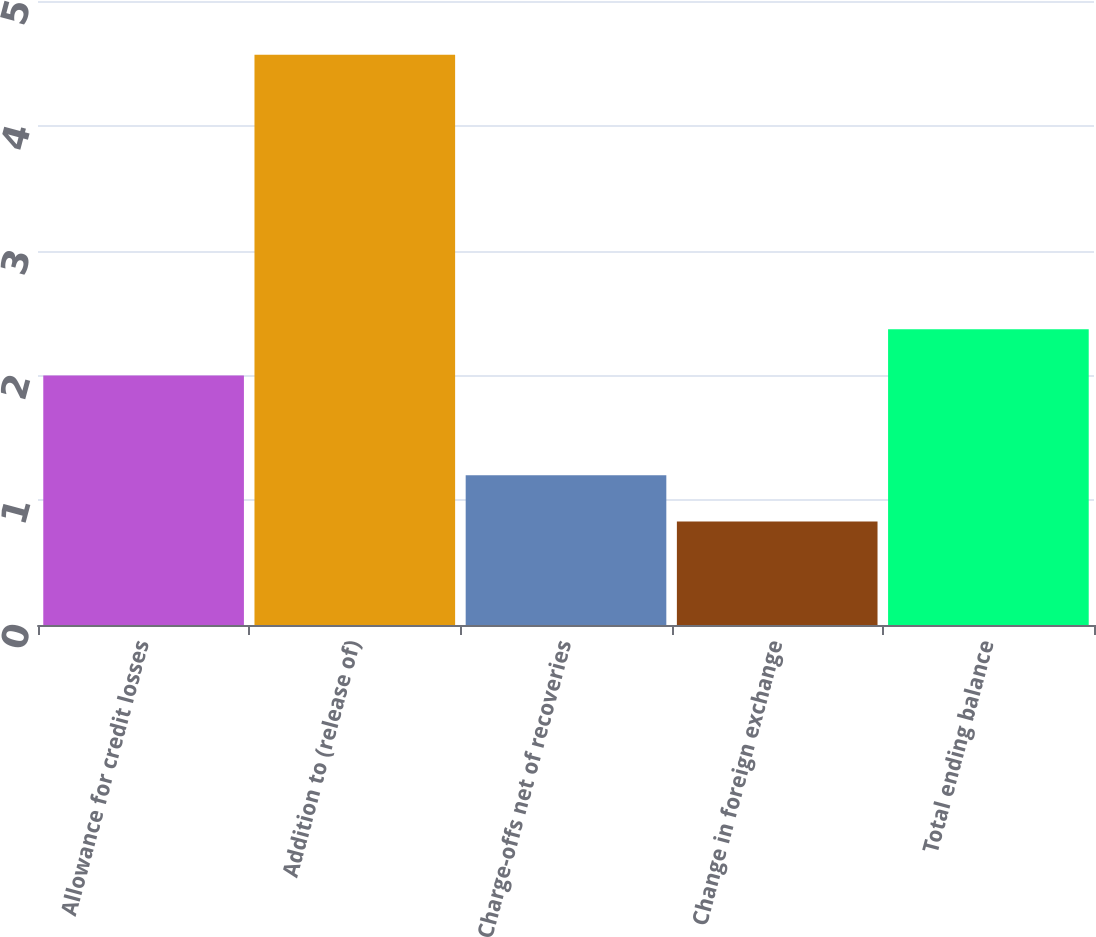Convert chart. <chart><loc_0><loc_0><loc_500><loc_500><bar_chart><fcel>Allowance for credit losses<fcel>Addition to (release of)<fcel>Charge-offs net of recoveries<fcel>Change in foreign exchange<fcel>Total ending balance<nl><fcel>2<fcel>4.57<fcel>1.2<fcel>0.83<fcel>2.37<nl></chart> 